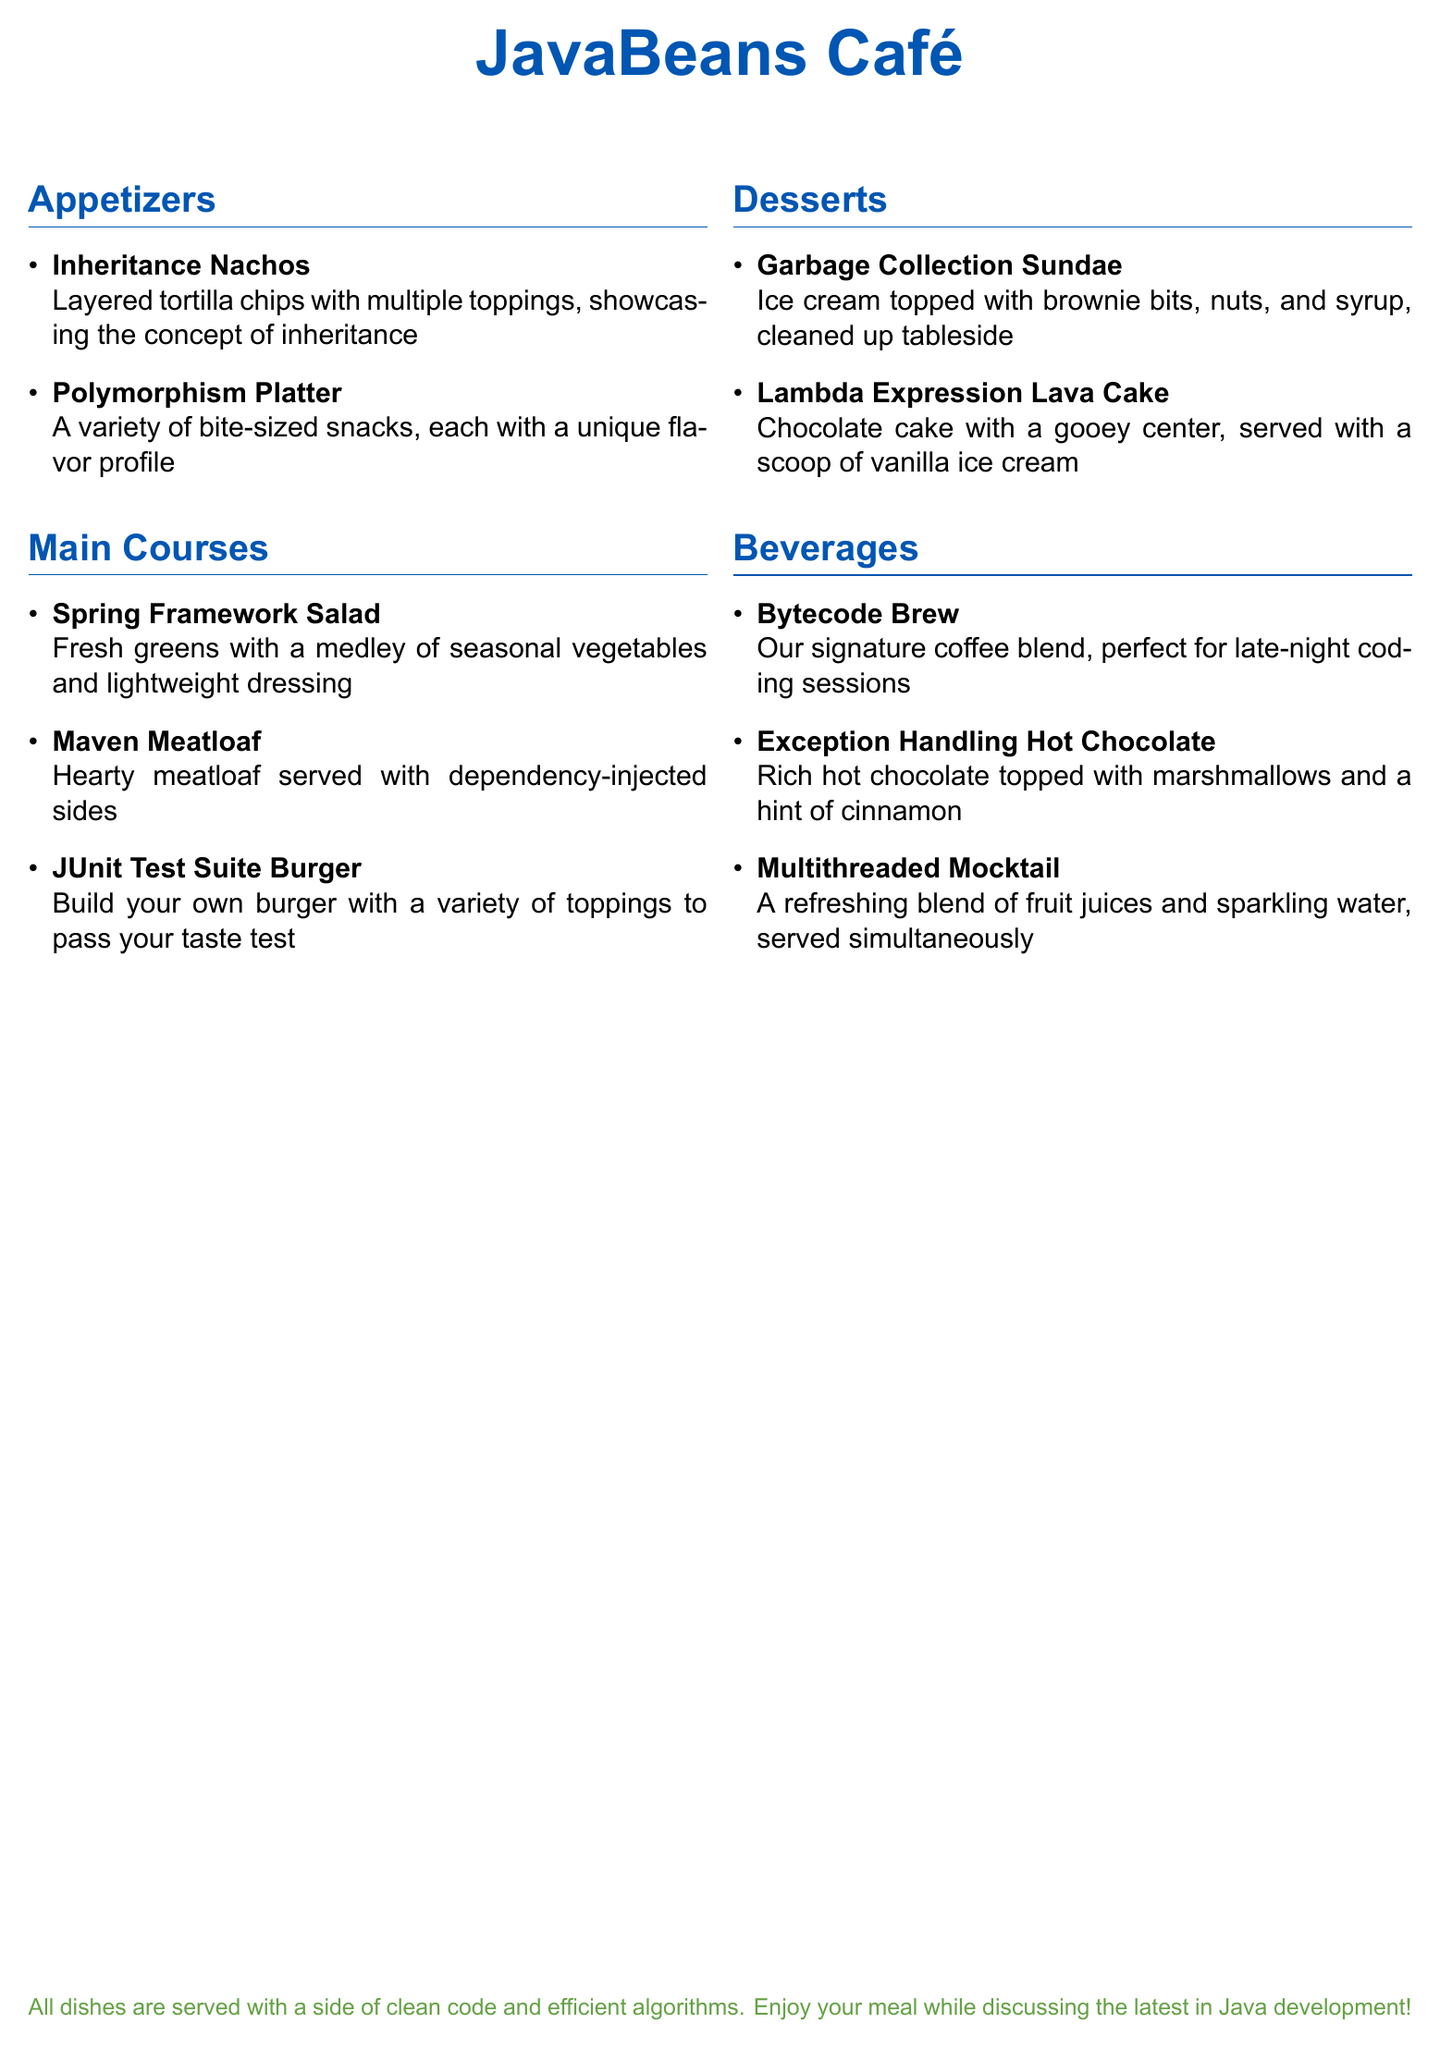What is the name of the café? The name of the café is prominently displayed at the top of the document.
Answer: JavaBeans Café How many appetizers are listed on the menu? The appetizers section contains a list of items, specifically two appetizers.
Answer: 2 What is one dessert option on the menu? The desserts section includes several items, one of which is easily named.
Answer: Garbage Collection Sundae What is served with the Maven Meatloaf? The description notes that it comes with specific types of sides, elaborating on the dish.
Answer: Dependency-injected sides What beverage is described as perfect for late-night coding sessions? The beverages section highlights one drink that suits this purpose well.
Answer: Bytecode Brew Which dish represents the concept of polymorphism? The document specifies a dish that showcases this programming principle.
Answer: Polymorphism Platter What color is used for the café's name? The document indicates a specific color used for the café's name at the top.
Answer: Javablue What type of salad is featured as a main course? The menu lists a salad that aligns with a particular framework in programming.
Answer: Spring Framework Salad What dessert has a gooey center? The description of a dessert highlights its unique characteristic in the document.
Answer: Lambda Expression Lava Cake 